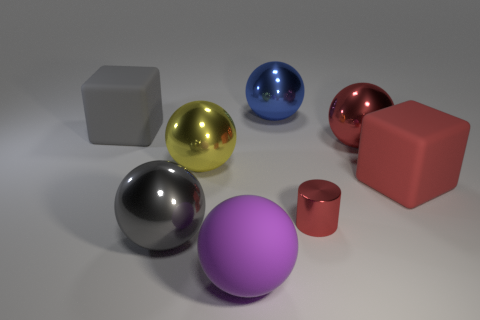Subtract all green spheres. Subtract all cyan blocks. How many spheres are left? 5 Add 1 red things. How many objects exist? 9 Subtract all spheres. How many objects are left? 3 Add 2 yellow shiny balls. How many yellow shiny balls are left? 3 Add 1 big red shiny spheres. How many big red shiny spheres exist? 2 Subtract 0 cyan cylinders. How many objects are left? 8 Subtract all big red matte cylinders. Subtract all large gray balls. How many objects are left? 7 